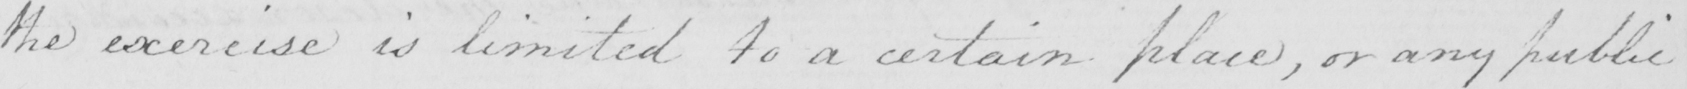Please transcribe the handwritten text in this image. the exercise is limited to a certain place , or any public 